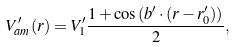<formula> <loc_0><loc_0><loc_500><loc_500>V ^ { \prime } _ { a m } ( { r } ) = V ^ { \prime } _ { 1 } \frac { 1 + \cos { ( { b ^ { \prime } } \cdot ( { r } - { r } ^ { \prime } _ { 0 } ) ) } } { 2 } ,</formula> 